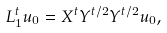Convert formula to latex. <formula><loc_0><loc_0><loc_500><loc_500>L ^ { t } _ { 1 } u _ { 0 } = X ^ { t } Y ^ { t / 2 } Y ^ { t / 2 } u _ { 0 } ,</formula> 